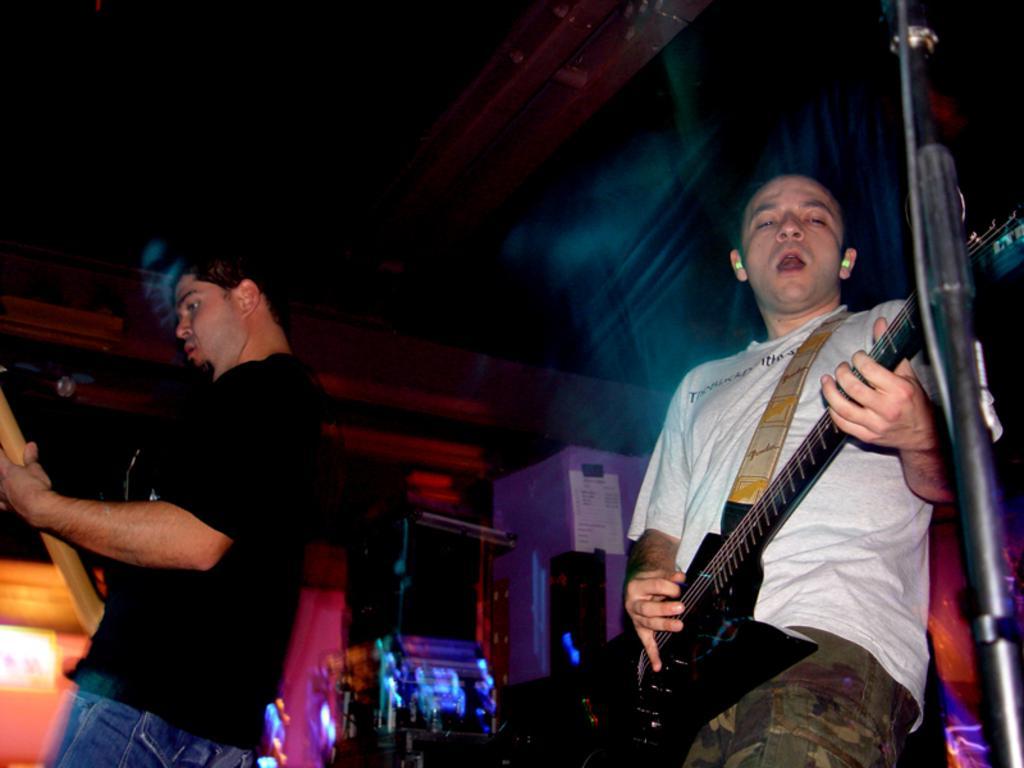In one or two sentences, can you explain what this image depicts? These 2 persons are playing guitar and singing. This is a mic holder. This man wore black t-shirt. This man wore white t-shirt. A poster on wall. 